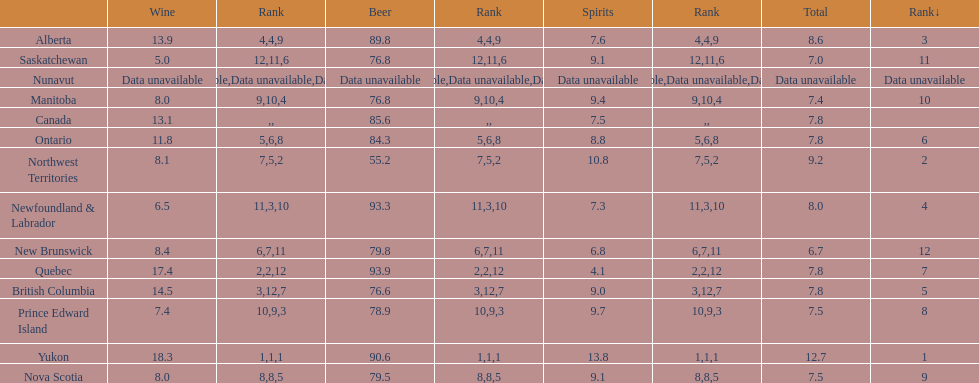Which province is the top consumer of wine? Yukon. Write the full table. {'header': ['', 'Wine', 'Rank', 'Beer', 'Rank', 'Spirits', 'Rank', 'Total', 'Rank↓'], 'rows': [['Alberta', '13.9', '4', '89.8', '4', '7.6', '9', '8.6', '3'], ['Saskatchewan', '5.0', '12', '76.8', '11', '9.1', '6', '7.0', '11'], ['Nunavut', 'Data unavailable', 'Data unavailable', 'Data unavailable', 'Data unavailable', 'Data unavailable', 'Data unavailable', 'Data unavailable', 'Data unavailable'], ['Manitoba', '8.0', '9', '76.8', '10', '9.4', '4', '7.4', '10'], ['Canada', '13.1', '', '85.6', '', '7.5', '', '7.8', ''], ['Ontario', '11.8', '5', '84.3', '6', '8.8', '8', '7.8', '6'], ['Northwest Territories', '8.1', '7', '55.2', '5', '10.8', '2', '9.2', '2'], ['Newfoundland & Labrador', '6.5', '11', '93.3', '3', '7.3', '10', '8.0', '4'], ['New Brunswick', '8.4', '6', '79.8', '7', '6.8', '11', '6.7', '12'], ['Quebec', '17.4', '2', '93.9', '2', '4.1', '12', '7.8', '7'], ['British Columbia', '14.5', '3', '76.6', '12', '9.0', '7', '7.8', '5'], ['Prince Edward Island', '7.4', '10', '78.9', '9', '9.7', '3', '7.5', '8'], ['Yukon', '18.3', '1', '90.6', '1', '13.8', '1', '12.7', '1'], ['Nova Scotia', '8.0', '8', '79.5', '8', '9.1', '5', '7.5', '9']]} 